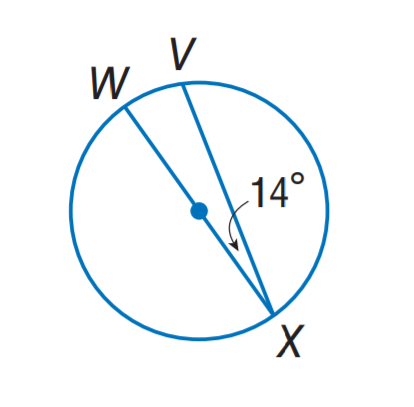Answer the mathemtical geometry problem and directly provide the correct option letter.
Question: Find m \widehat V X.
Choices: A: 28 B: 71 C: 152 D: 166 C 